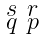<formula> <loc_0><loc_0><loc_500><loc_500>\begin{smallmatrix} s & r \\ q & p \end{smallmatrix}</formula> 